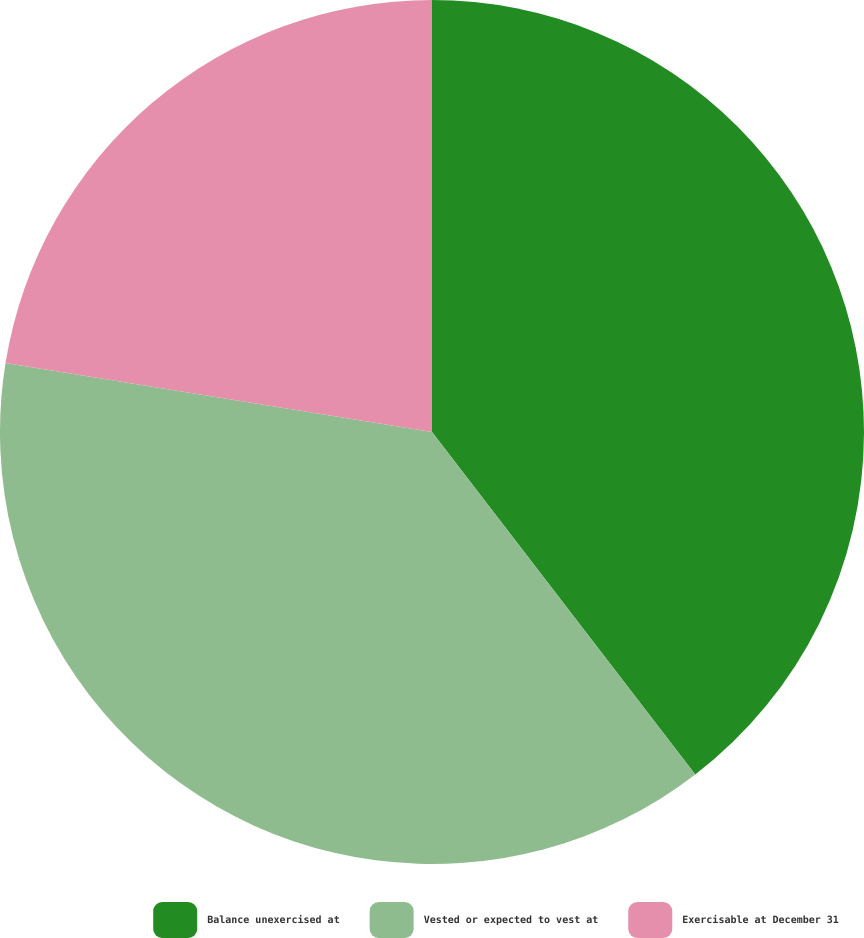Convert chart to OTSL. <chart><loc_0><loc_0><loc_500><loc_500><pie_chart><fcel>Balance unexercised at<fcel>Vested or expected to vest at<fcel>Exercisable at December 31<nl><fcel>39.57%<fcel>37.98%<fcel>22.45%<nl></chart> 